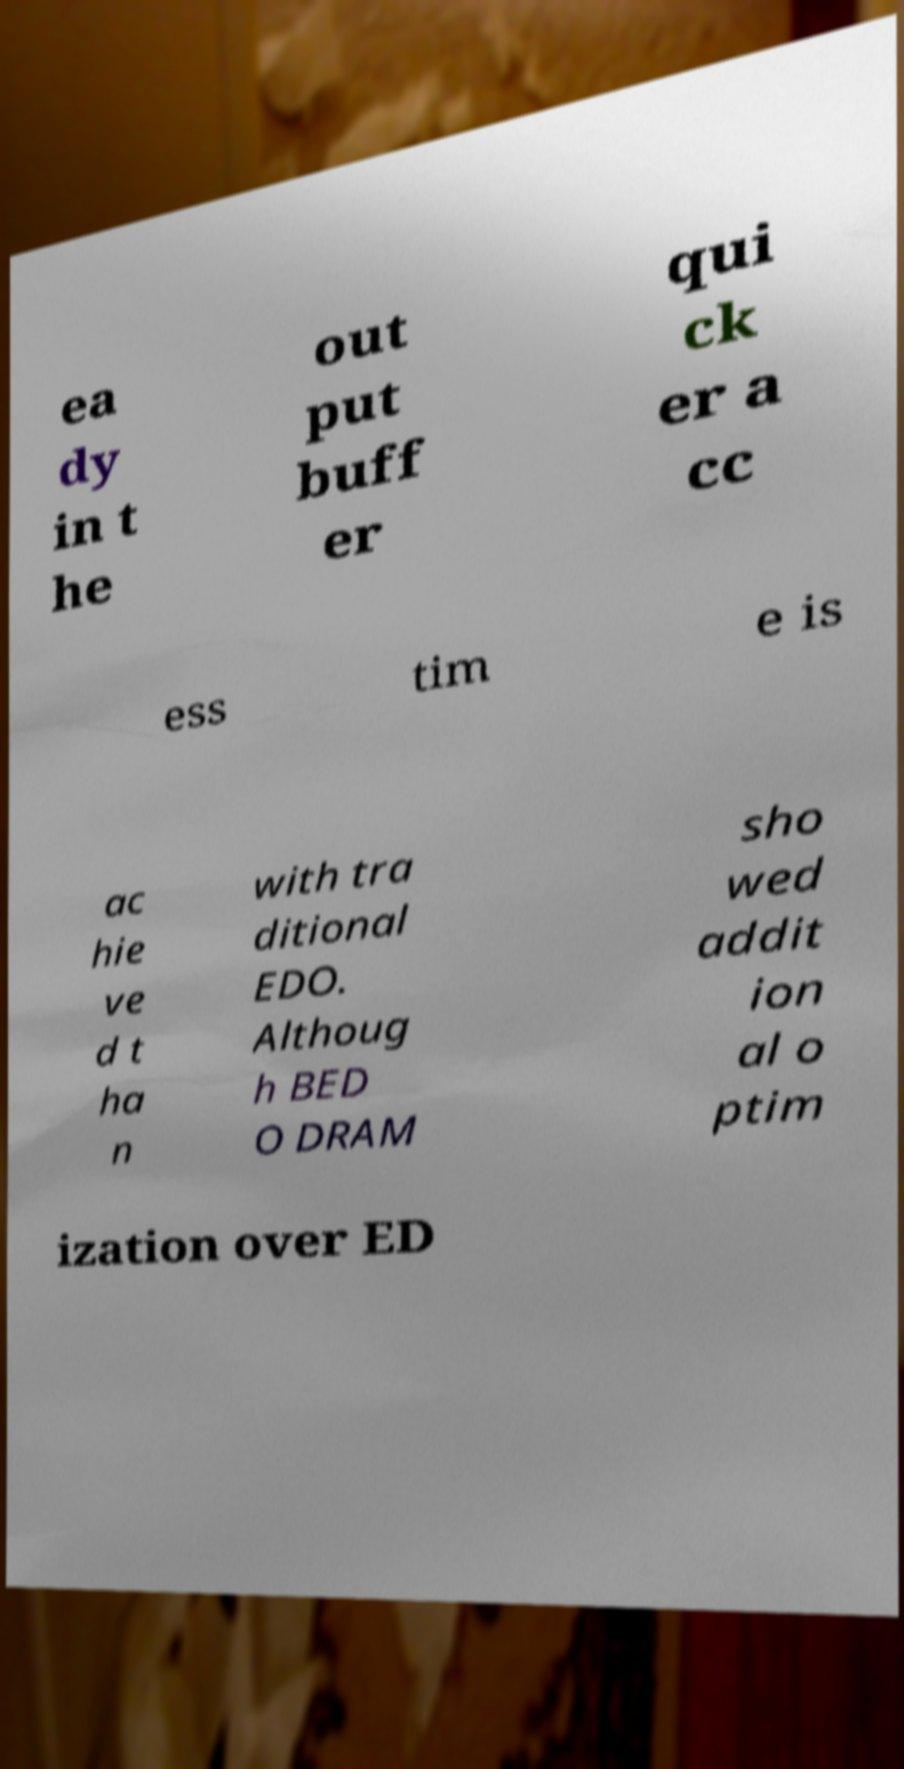For documentation purposes, I need the text within this image transcribed. Could you provide that? ea dy in t he out put buff er qui ck er a cc ess tim e is ac hie ve d t ha n with tra ditional EDO. Althoug h BED O DRAM sho wed addit ion al o ptim ization over ED 